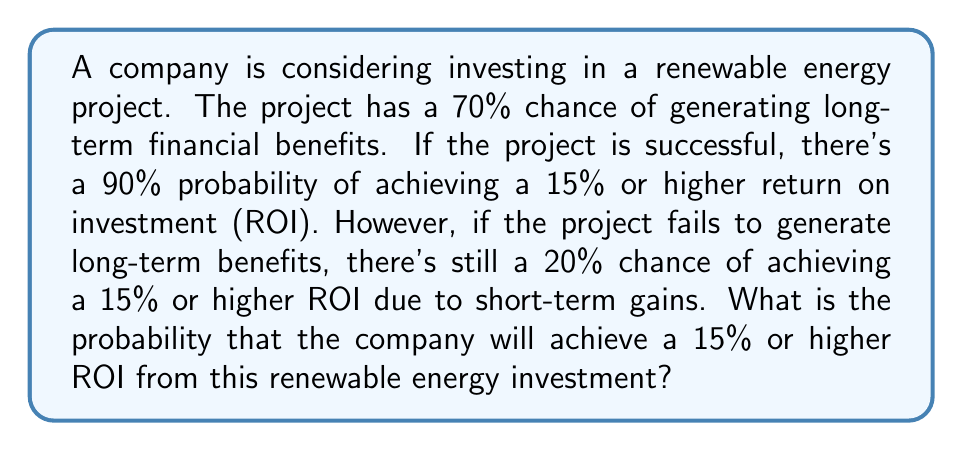What is the answer to this math problem? Let's approach this step-by-step using the law of total probability:

1) Define events:
   A: Achieve 15% or higher ROI
   B: Project generates long-term financial benefits

2) We need to find P(A), which can be calculated as:
   $$P(A) = P(A|B) \cdot P(B) + P(A|\text{not }B) \cdot P(\text{not }B)$$

3) Given:
   P(B) = 0.70 (70% chance of long-term benefits)
   P(A|B) = 0.90 (90% chance of 15%+ ROI if successful)
   P(A|not B) = 0.20 (20% chance of 15%+ ROI if unsuccessful)
   P(not B) = 1 - P(B) = 1 - 0.70 = 0.30

4) Substitute into the formula:
   $$P(A) = 0.90 \cdot 0.70 + 0.20 \cdot 0.30$$

5) Calculate:
   $$P(A) = 0.63 + 0.06 = 0.69$$

Therefore, the probability of achieving a 15% or higher ROI is 0.69 or 69%.
Answer: 0.69 